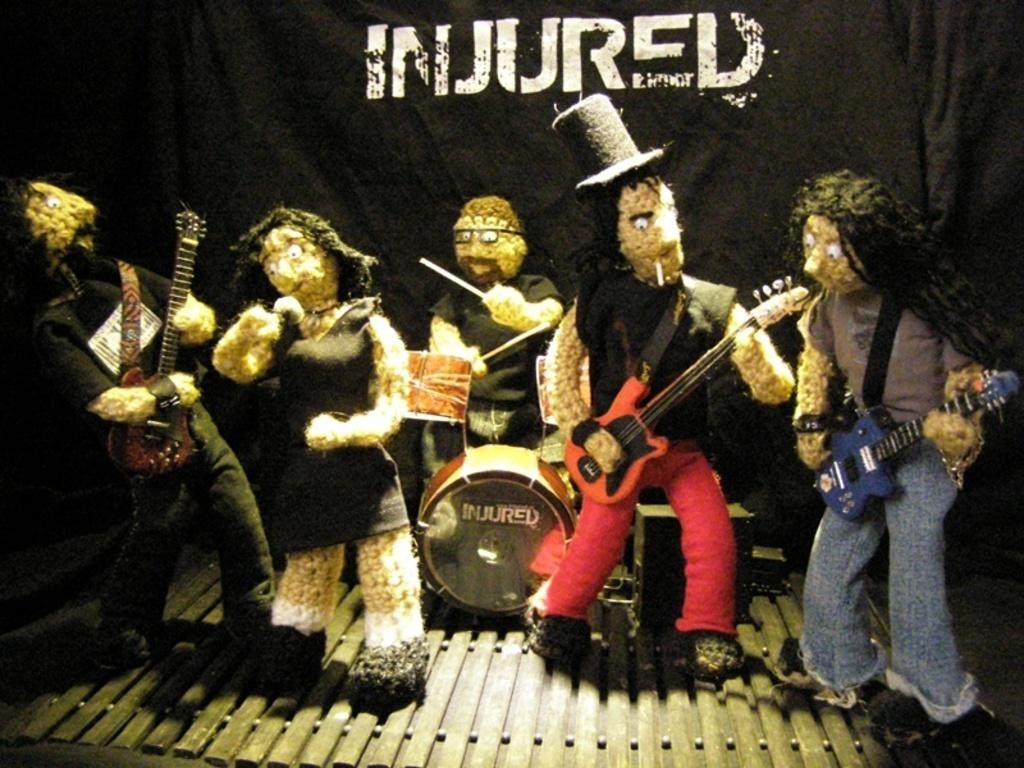What is the main subject of the image? The main subject of the image is a group of toys. What are the toys doing in the image? The toys are playing music. What can be seen in the background of the image? There is a black cloth in the background of the image. What is written on the black cloth? The word "injured" is written on the black cloth. What type of stocking is visible on the toys in the image? There are no stockings visible on the toys in the image. What kind of border is present around the toys in the image? There is no border present around the toys in the image. 